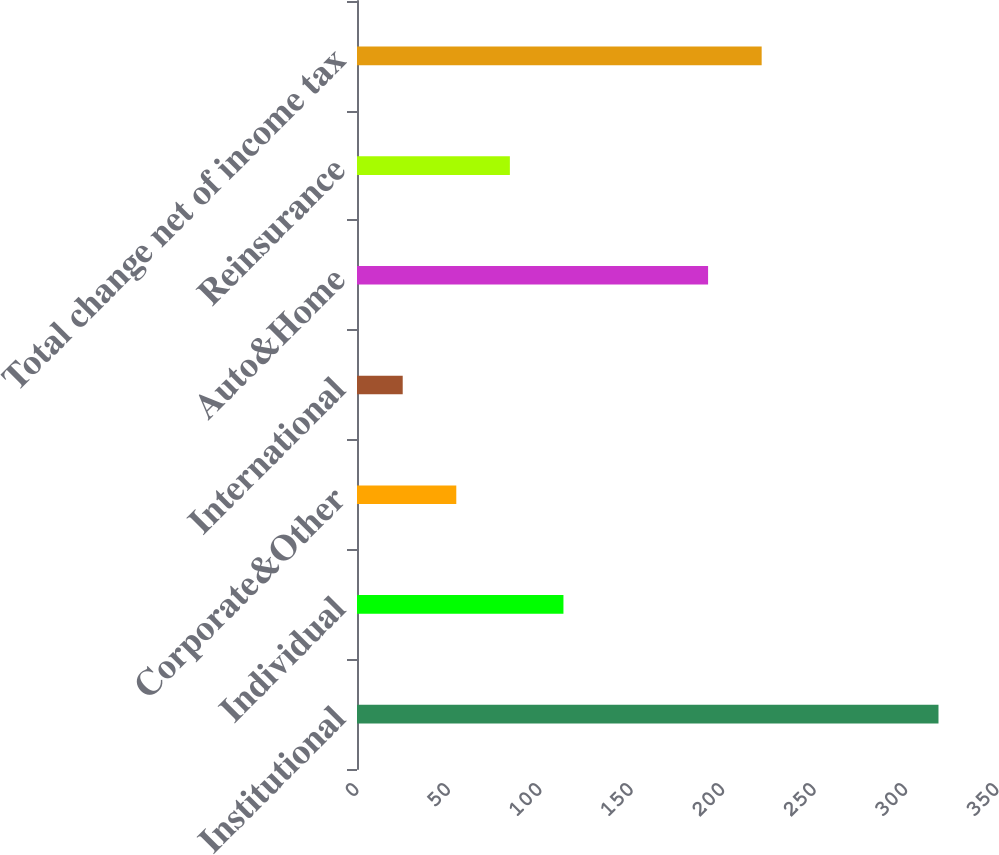Convert chart to OTSL. <chart><loc_0><loc_0><loc_500><loc_500><bar_chart><fcel>Institutional<fcel>Individual<fcel>Corporate&Other<fcel>International<fcel>Auto&Home<fcel>Reinsurance<fcel>Total change net of income tax<nl><fcel>318<fcel>112.9<fcel>54.3<fcel>25<fcel>192<fcel>83.6<fcel>221.3<nl></chart> 